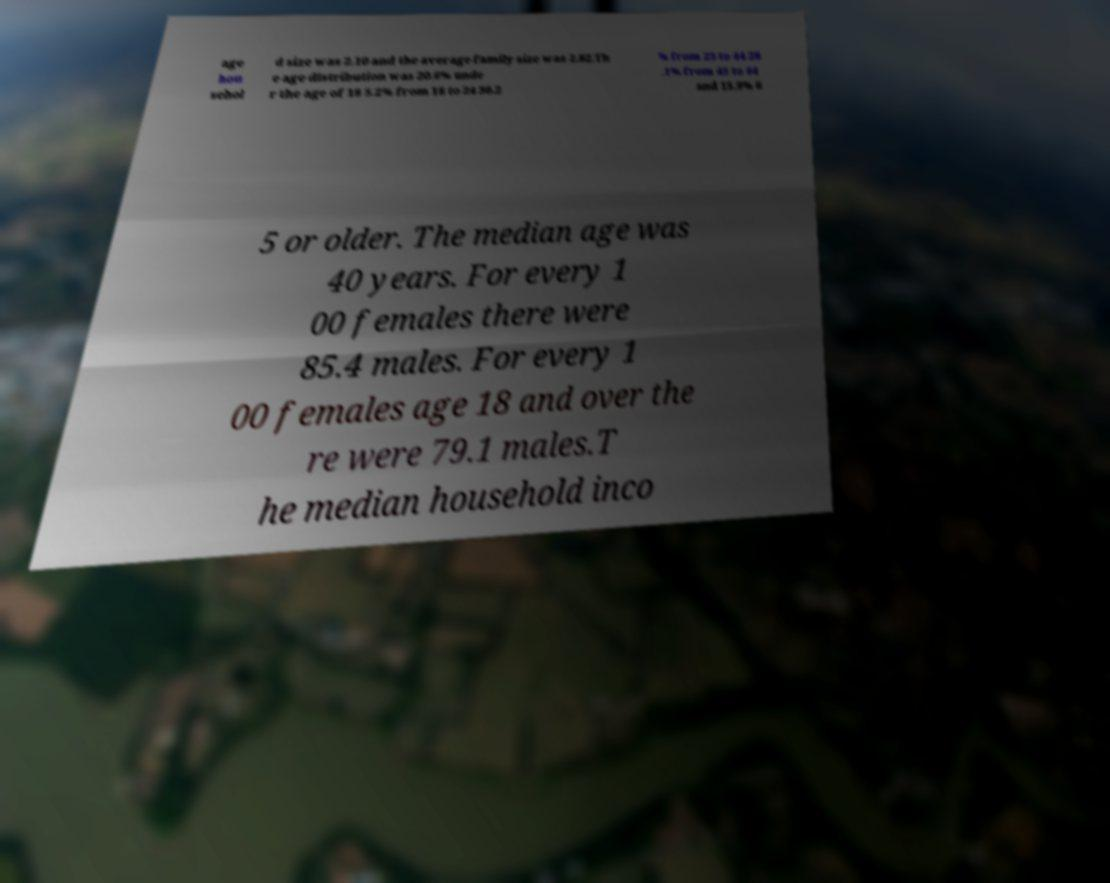Could you assist in decoding the text presented in this image and type it out clearly? age hou sehol d size was 2.10 and the average family size was 2.82.Th e age distribution was 20.6% unde r the age of 18 5.2% from 18 to 24 30.2 % from 25 to 44 28 .1% from 45 to 64 and 15.9% 6 5 or older. The median age was 40 years. For every 1 00 females there were 85.4 males. For every 1 00 females age 18 and over the re were 79.1 males.T he median household inco 